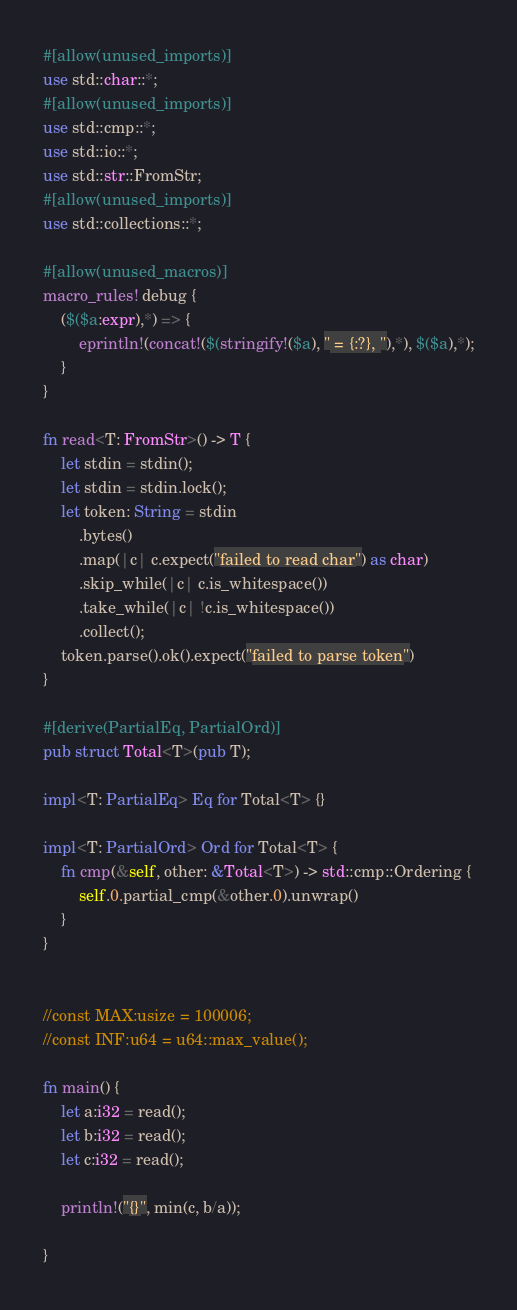Convert code to text. <code><loc_0><loc_0><loc_500><loc_500><_Rust_>#[allow(unused_imports)]
use std::char::*;
#[allow(unused_imports)]
use std::cmp::*;
use std::io::*;
use std::str::FromStr;
#[allow(unused_imports)]
use std::collections::*;

#[allow(unused_macros)]
macro_rules! debug {
    ($($a:expr),*) => {
        eprintln!(concat!($(stringify!($a), " = {:?}, "),*), $($a),*);
    }
}

fn read<T: FromStr>() -> T {
    let stdin = stdin();
    let stdin = stdin.lock();
    let token: String = stdin
        .bytes()
        .map(|c| c.expect("failed to read char") as char)
        .skip_while(|c| c.is_whitespace())
        .take_while(|c| !c.is_whitespace())
        .collect();
    token.parse().ok().expect("failed to parse token")
}

#[derive(PartialEq, PartialOrd)]
pub struct Total<T>(pub T);

impl<T: PartialEq> Eq for Total<T> {}

impl<T: PartialOrd> Ord for Total<T> {
    fn cmp(&self, other: &Total<T>) -> std::cmp::Ordering {
        self.0.partial_cmp(&other.0).unwrap()
    }
}


//const MAX:usize = 100006;
//const INF:u64 = u64::max_value();

fn main() {
    let a:i32 = read();
    let b:i32 = read();
    let c:i32 = read();

    println!("{}", min(c, b/a));

}
</code> 